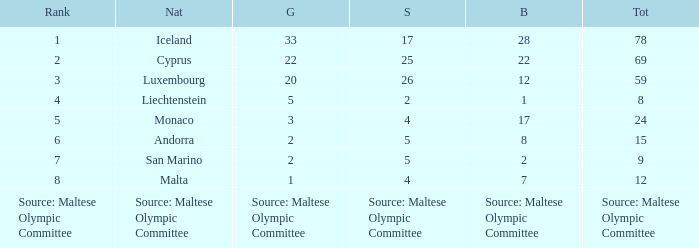What rank is the nation with 2 silver medals? 4.0. 